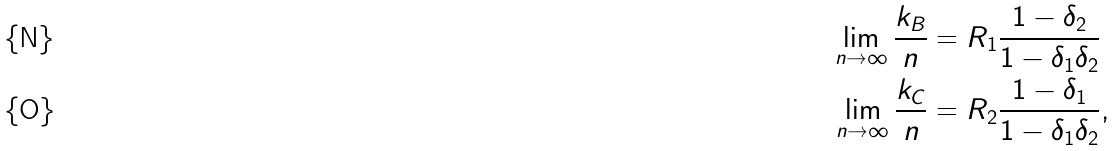Convert formula to latex. <formula><loc_0><loc_0><loc_500><loc_500>\lim _ { n \rightarrow \infty } \frac { k _ { B } } { n } & = R _ { 1 } \frac { 1 - \delta _ { 2 } } { 1 - \delta _ { 1 } \delta _ { 2 } } \\ \lim _ { n \rightarrow \infty } \frac { k _ { C } } { n } & = R _ { 2 } \frac { 1 - \delta _ { 1 } } { 1 - \delta _ { 1 } \delta _ { 2 } } ,</formula> 